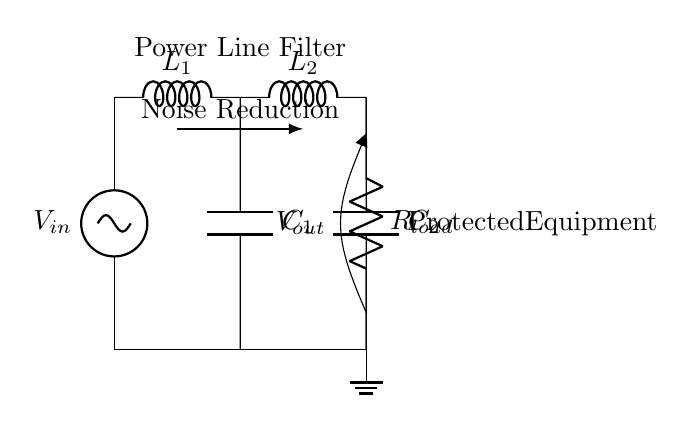What is the input voltage labeled in the circuit? The input voltage is labeled as V_in, which is located at the top of the circuit diagram near the power source.
Answer: V_in What components are present in this filter circuit? The circuit includes two inductors (L1, L2), two capacitors (C1, C2), a resistor (R_load), and a voltage source labeled as V_in.
Answer: Inductor, Capacitor, Resistor How many inductors are used in this power line filter? The circuit diagram clearly shows two inductors labeled L1 and L2, connected in series to filter the input voltage.
Answer: Two What is the function of the capacitors in this filter circuit? The capacitors (C1 and C2) are used to filter out voltage fluctuations and noise, improving the stability of the output voltage (V_out) for the protected equipment.
Answer: Noise filtering What is the role of the resistor in this circuit? The resistor labeled R_load represents the load that the filtered voltage is powering, serving as a point where the filtered voltage is applied.
Answer: Load What does the arrow labeled "Noise Reduction" indicate in the circuit? The arrow highlights the primary function of the filter circuit, which is to reduce noise between the input and output, ensuring that the sensitive equipment receives a cleaner voltage input.
Answer: Noise reduction What is the output voltage labeled in the circuit? The output voltage is labeled as V_out, positioned at the bottom of the circuit near the load resistor, indicating the voltage supplied to the protected equipment.
Answer: V_out 